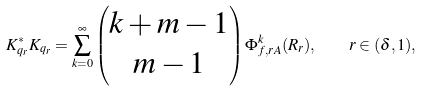<formula> <loc_0><loc_0><loc_500><loc_500>K _ { q _ { r } } ^ { * } K _ { q _ { r } } = \sum _ { k = 0 } ^ { \infty } \left ( \begin{matrix} k + m - 1 \\ m - 1 \end{matrix} \right ) \Phi _ { f , r A } ^ { k } ( R _ { r } ) , \quad r \in ( \delta , 1 ) ,</formula> 